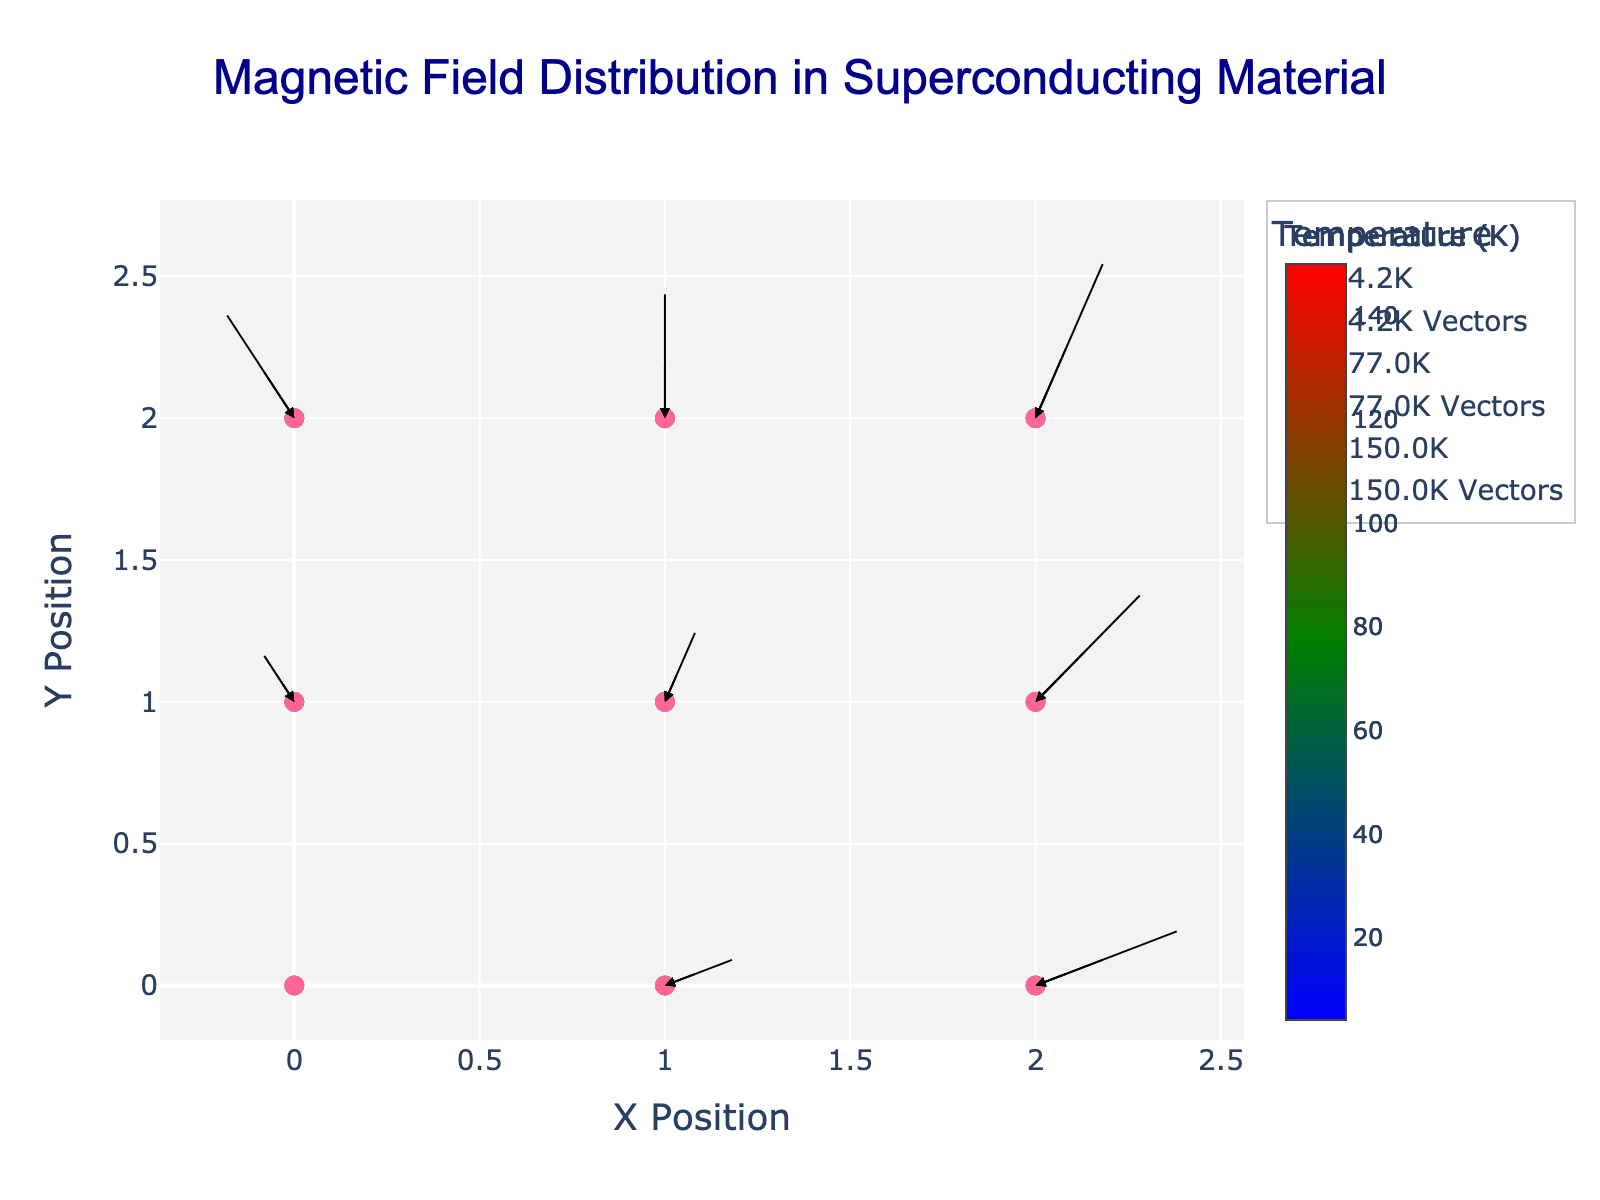What is the title of the quiver plot? The title of the quiver plot is usually located at the top center of the chart. By examining this area, we see the title is "Magnetic Field Distribution in Superconducting Material".
Answer: Magnetic Field Distribution in Superconducting Material Which axes are labeled, and what are their labels? The axes names are typically located adjacent to the start of the axis lines. By inspecting the figure, you will see that the X-axis is labeled as "X Position", and the Y-axis is labeled as "Y Position".
Answer: X Position, Y Position What visual elements are used to differentiate the temperatures? The figure uses different marker colors to represent different temperatures. The exact color range stretches from blue, green to red, indicating varying temperature levels. Additionally, there is a color scale or color bar that shows the temperature in Kelvin.
Answer: Marker colors How does the magnetic field vector at position (1, 0) change with temperature? To determine this, examine the arrows starting at (1,0) for each temperature. At 4.2K, the vector is (0.2, 0.1). At 77K, it's (0.1, 0.05). At 150K, it is (0.05, 0.025).
Answer: Decreases as temperature increases Compare the magnetic field strengths (magnitude) at position (1, 1) for all temperatures. The magnetic field strength can be found by examining the vector lengths. To calculate the magnitudes: sqrt(0.1^2 + 0.3^2)=0.316 at 4.2K, sqrt(0.05^2 + 0.15^2)=0.158 at 77K, and sqrt(0.025^2 + 0.075^2)=0.079 at 150K.
Answer: 0.316, 0.158, 0.079 How does the magnetic field vector change at position (0, 1) as temperature increases from 4.2K to 150K? For each temperature, check the vectors at (0,1). At 4.2K, the vector is (-0.1, 0.2). At 77K, it's (-0.05, 0.1). At 150K, it's (-0.025, 0.05). The vectors' magnitudes and directions decrease with temperature.
Answer: Magnitudes and directions decrease At position (2, 0), which temperature corresponds to the longest magnetic field vector? Vector length is calculated as sqrt(Bx^2 + By^2). For (2,0), at 4.2K it's sqrt(0.4^2 + 0.2^2)=0.447, at 77K it's sqrt(0.2^2 + 0.1^2)=0.224, and at 150K it's sqrt(0.1^2+ 0.05^2)=0.112. The longest vector is at 4.2K.
Answer: 4.2K 